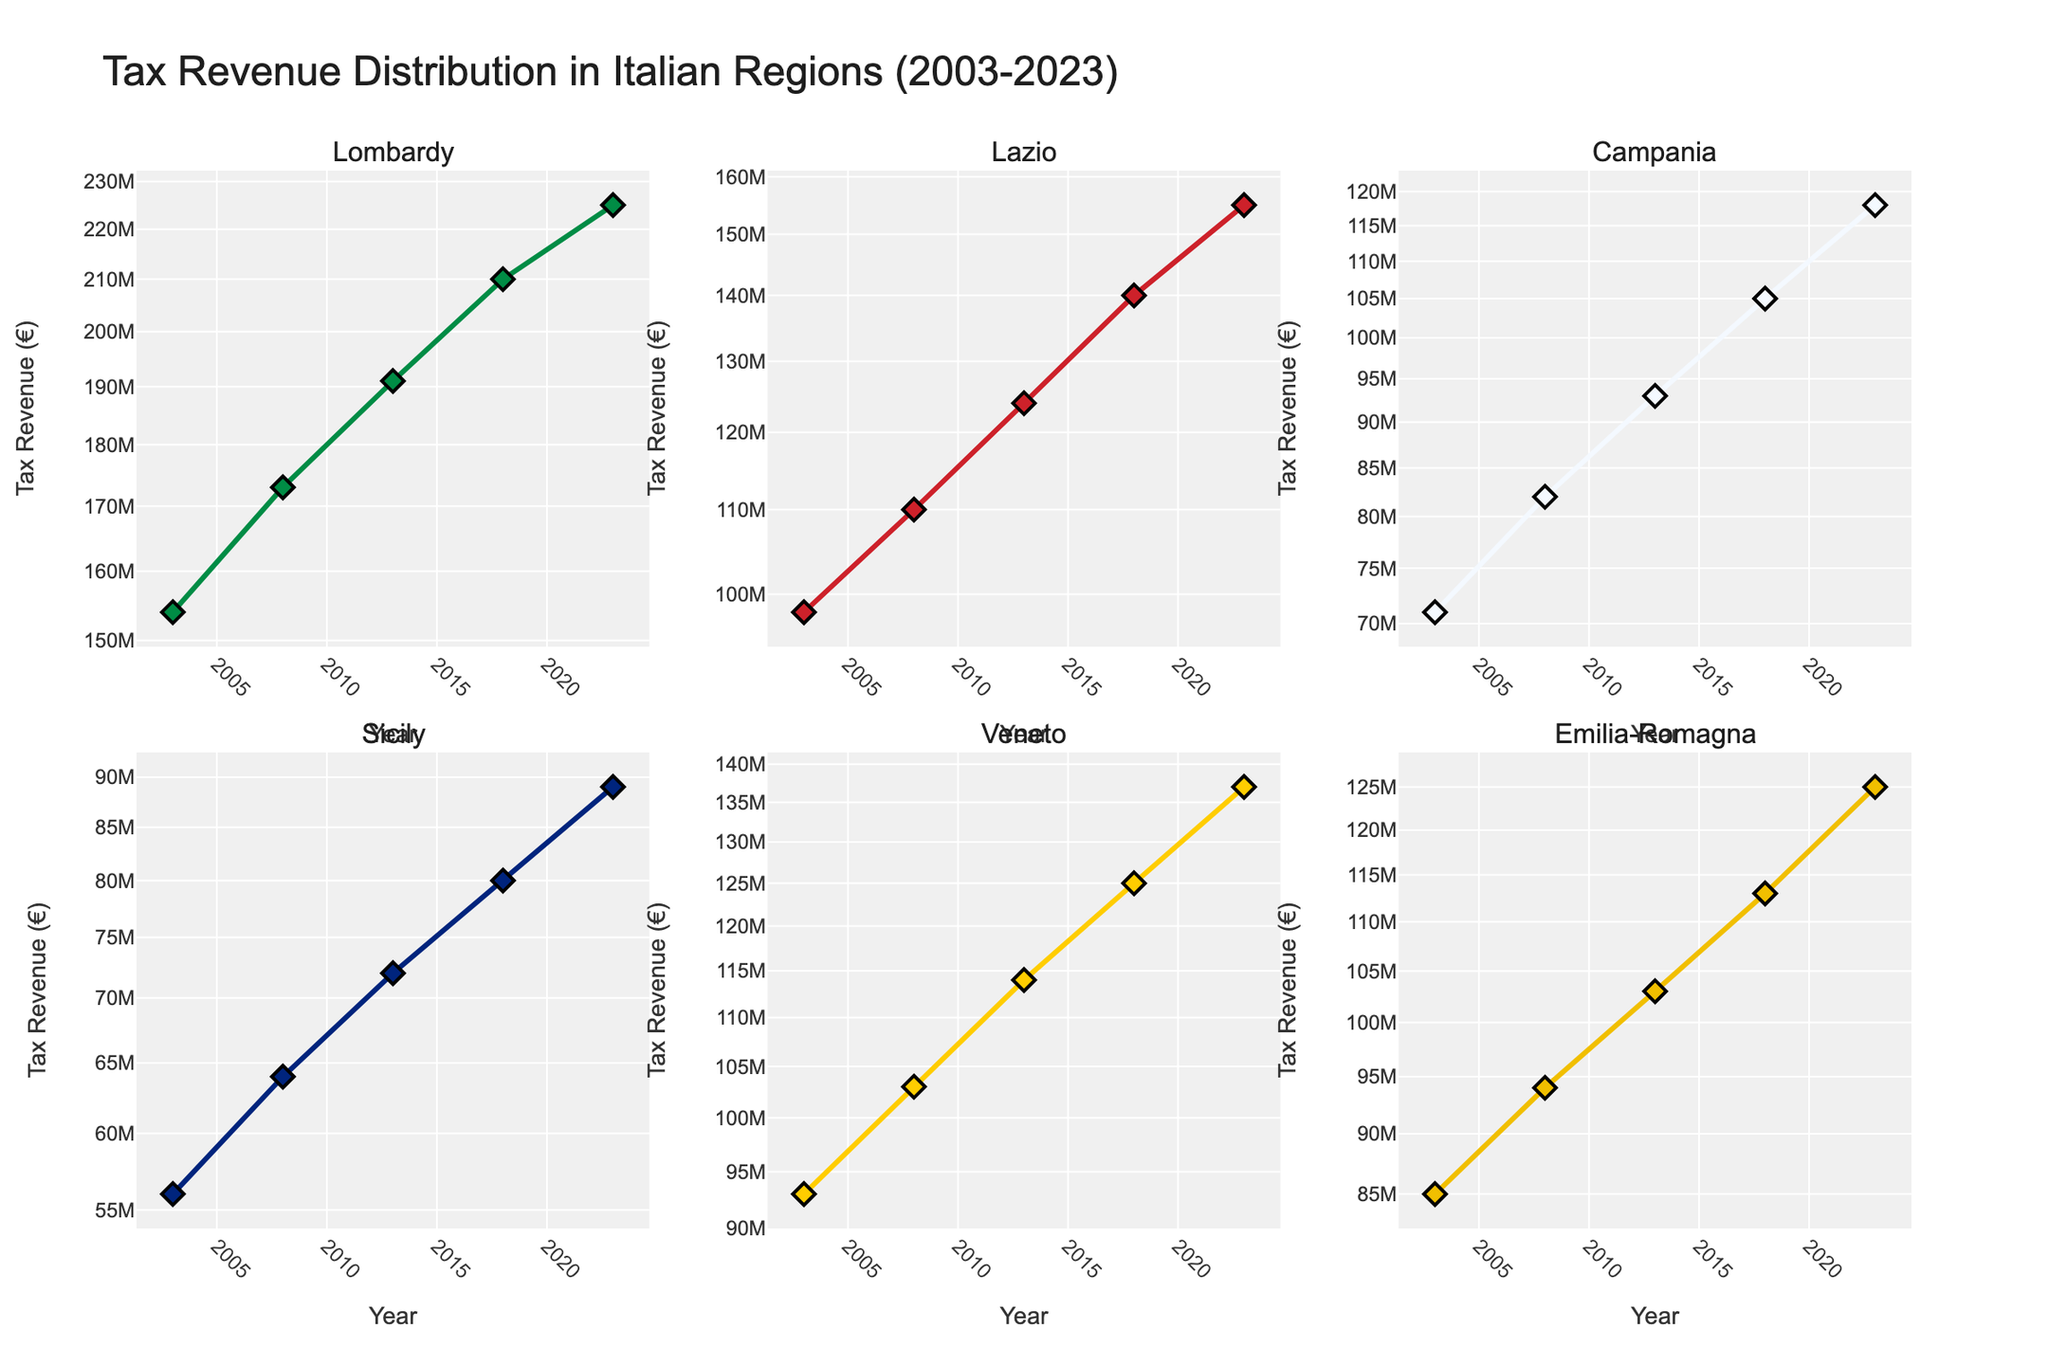How many distinct regions are represented in the figure? The subplot titles indicate each distinct region, and there are 6 titles corresponding to different regions in Italy.
Answer: 6 Which region had the highest tax revenue in 2023? The subplot for Lombardy shows the highest data point in 2023, indicating it has the highest tax revenue among all regions in that year.
Answer: Lombardy What is the range of tax revenues for Lazio between 2003 and 2023? The tax revenue for Lazio ranges from about 98 million in 2003 to 155 million in 2023, as observed from the y-axis values in Lazio's subplot.
Answer: 98 million to 155 million Which region shows the most significant increase in tax revenue over the two decades? Lombardy's subplot shows a significant increase from 154 million to 225 million from 2003 to 2023, which is the largest increase among all regions.
Answer: Lombardy Compare the growth in tax revenue between Campania and Sicily from 2003 to 2023. Which region had higher growth? Campania's tax revenue increased from 71 million to 118 million, while Sicily's grew from 56 million to 89 million. Thus, Campania had a higher growth in tax revenue.
Answer: Campania What trend do all regions show in their tax revenue from 2003 to 2023? Each subplot shows an upward trend in tax revenue for all regions over the two decades, indicating a consistent increase across the board.
Answer: Upward trend By what factor did the tax revenue grow in Veneto from 2003 to 2023? The tax revenue in Veneto grew from 93 million to 137 million over 20 years. The growth factor is 137 / 93 ≈ 1.47.
Answer: 1.47 Which region has the least tax revenue in 2023 and what is its value? The subplot for Sicily shows the lowest tax revenue in 2023, around 89 million, as depicted on the y-axis.
Answer: Sicily, 89 million How does the trend in Lazio’s tax revenue compare to Emilia-Romagna’s from 2003 to 2023? Both regions show an upward trend over the 20 years; however, Lazio's tax revenue grew from 98 million to 155 million, while Emilia-Romagna's increased from 85 million to 125 million, showing a slightly steeper growth for Lazio.
Answer: Lazio grew more steeply 